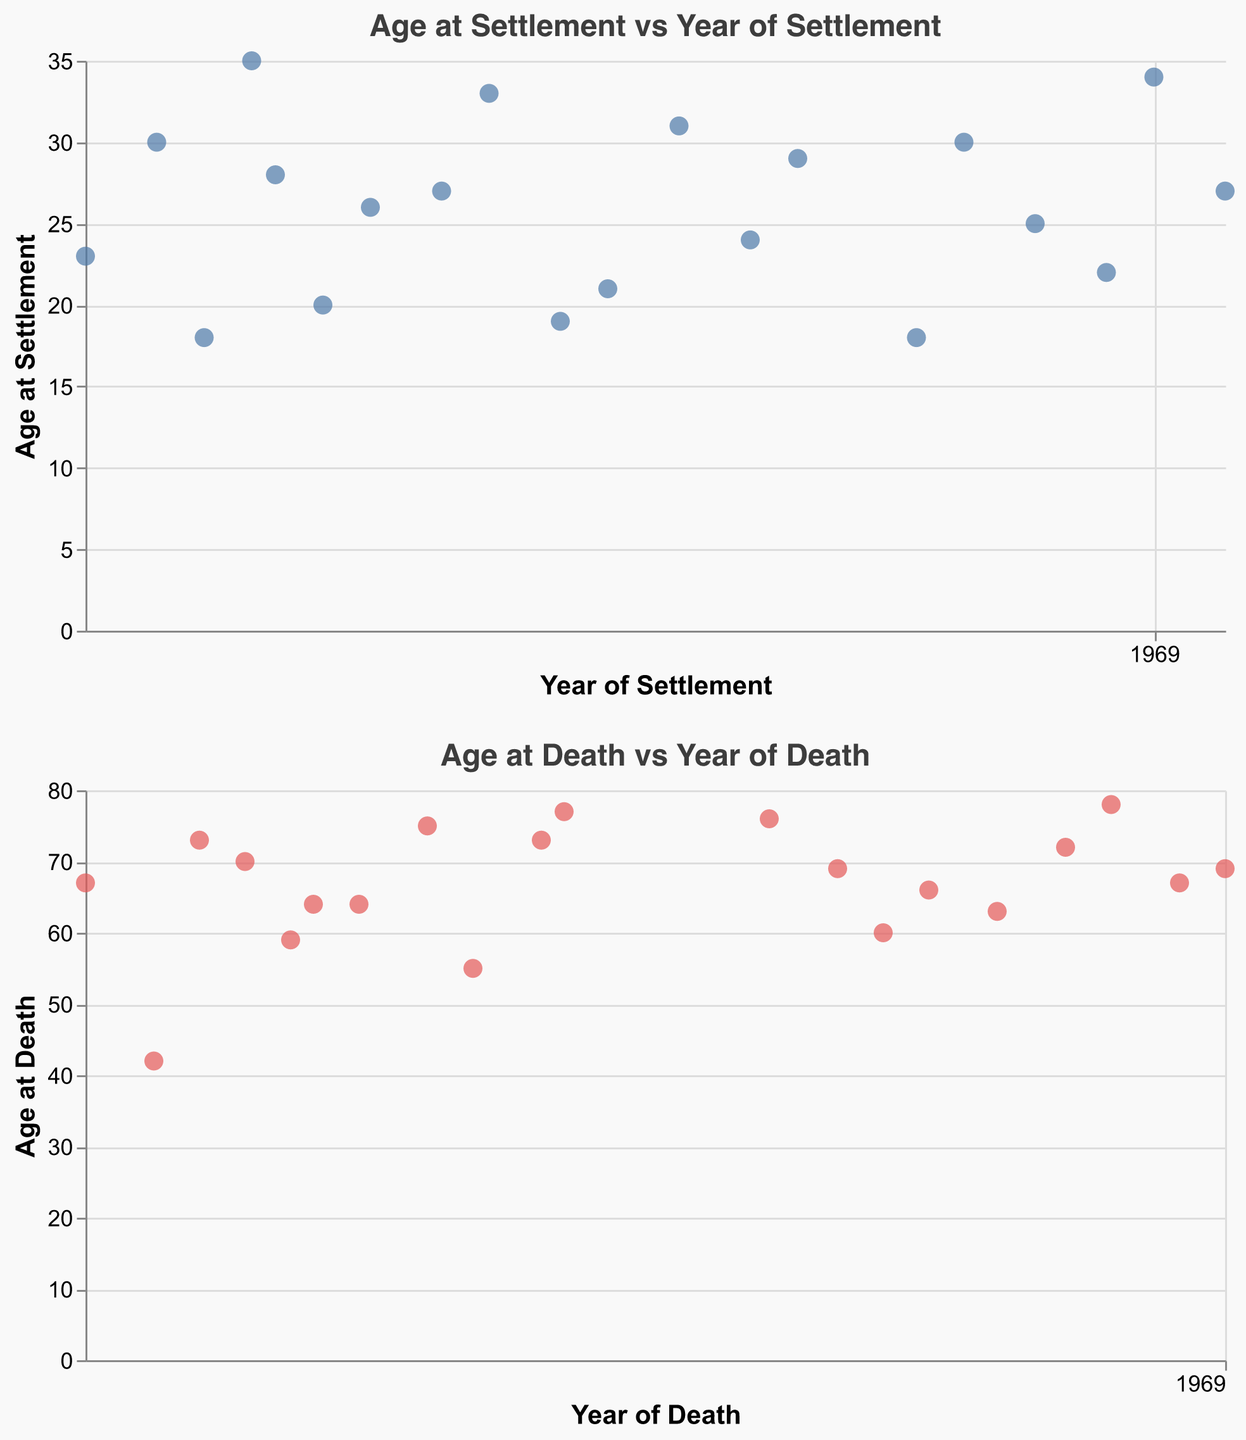What is the title of the first plot? The title can be found at the top of the first scatter plot.
Answer: Age at Settlement vs Year of Settlement What is the age at death of Steinunn Eyjolfsdottir? Look at the tooltip data or the y-axis of the second scatter plot near the point corresponding to Steinunn Eyjolfsdottir's year of death, 1932.
Answer: 55 What range of years does the second plot cover? Observe the x-axis range of the second scatter plot, which indicates the range from the earliest to the latest year of death.
Answer: 1915 to 1965 How many settlers were aged under 20 at the time of settlement? Check the y-axis of the first scatter plot, then count the number of points with a y-value (Age at Settlement) below 20.
Answer: 3 What is the average age at settlement for settlers who arrived before 1900? Identify the points in the first plot with x-values (Year of Settlement) before 1900. Calculate the average of the corresponding y-values (Age at Settlement). (23 + 30 + 18 + 35 + 28 + 20 + 26 + 27 + 33 + 19 + 21) / 11 = (280 / 11)
Answer: 25.5 Which settler lived the longest after their settlement? Find the difference between Age at Death and Age at Settlement for all settlers, then identify the maximum difference. (Thora Magnusdottir: 78 - 30 = 48 years)
Answer: Thora Magnusdottir How does the concentration of ages at death change over time? Observe the scatter pattern in the second plot. Note that earlier years might have more varied ages at death, while later years might show a tighter range.
Answer: Becomes more varied in earlier years, more concentrated in later years What is the median age at settlement? List the ages at settlement from the first scatter plot, sort them, and find the median value. (18, 18, 19, 20, 21, 23, 24, 25, 26, 27, 27, 28, 29, 30, 30, 31, 33, 34, 35) - The median is the 10th value in this ordered list.
Answer: 27 Are there more settlers aged above or below 30 at death? Count the number of points above and below 30 in the second scatter plot. (Above: 17, Below: 3)
Answer: More above 30 How many settlers lived beyond 70 years of age? Look at the y-axis of the second scatter plot and count the number of points above 70.
Answer: 6 